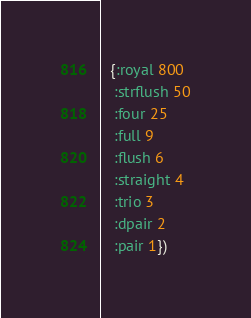<code> <loc_0><loc_0><loc_500><loc_500><_Clojure_>  {:royal 800
   :strflush 50
   :four 25
   :full 9
   :flush 6
   :straight 4
   :trio 3
   :dpair 2
   :pair 1})
</code> 